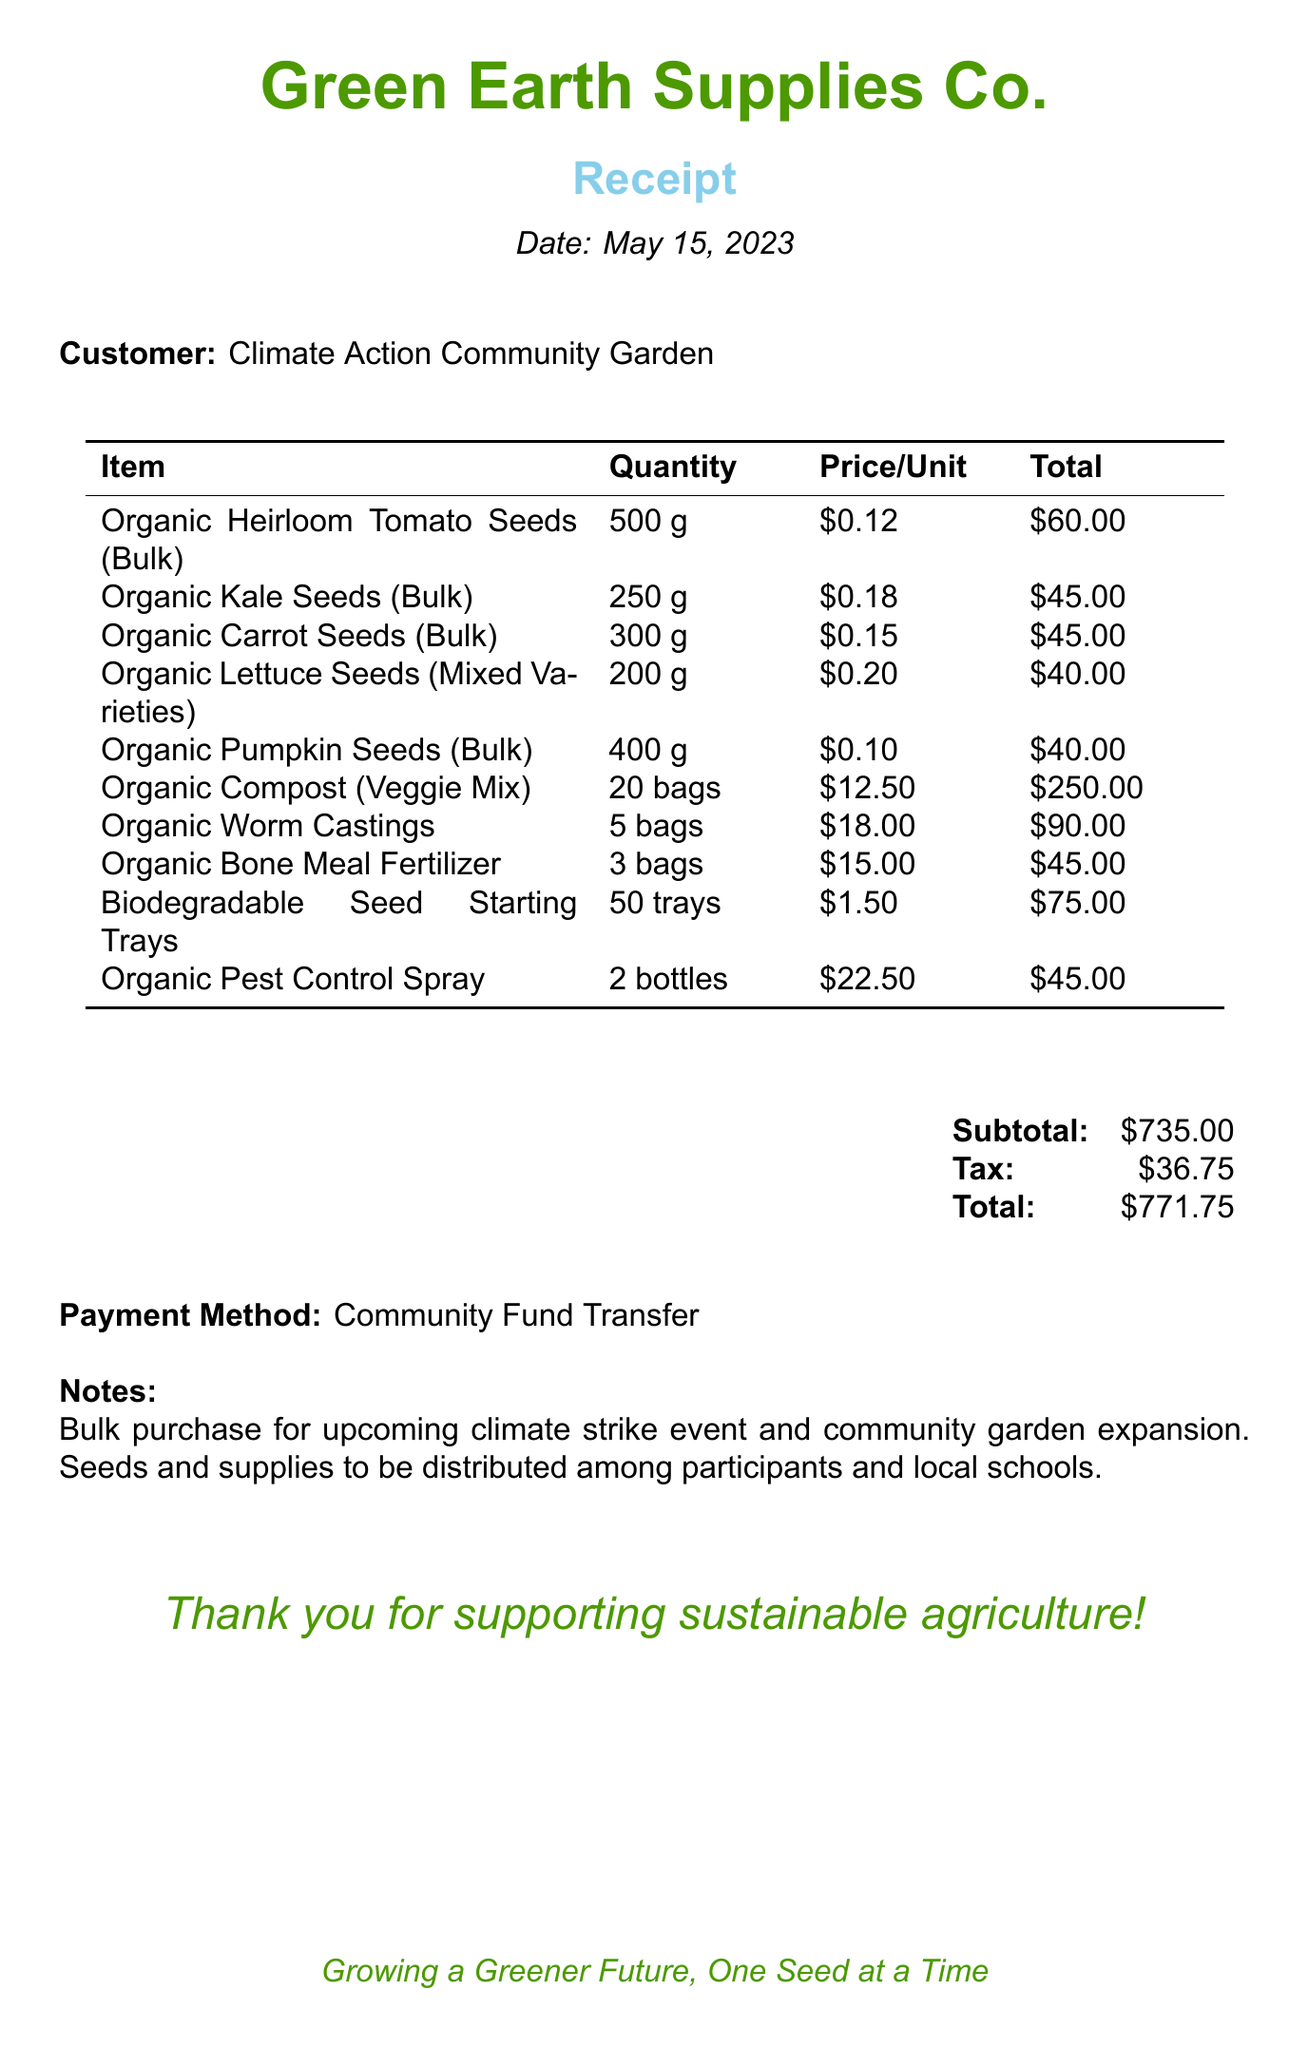What is the store name? The store name is mentioned at the top of the receipt.
Answer: Green Earth Supplies Co What date is the receipt issued? The date of the transaction is displayed under the title "Receipt."
Answer: May 15, 2023 What is the total amount paid? The total amount is calculated including subtotal and tax.
Answer: $771.75 How many grams of Organic Heirloom Tomato Seeds were purchased? The quantity of Organic Heirloom Tomato Seeds is listed in the itemized section.
Answer: 500 grams What type of payment was used? The payment method is indicated towards the end of the receipt.
Answer: Community Fund Transfer What is the subtotal before tax? The subtotal is displayed in the financial summary section before tax is added.
Answer: $735.00 How many bags of Organic Compost were bought? The quantity is clearly stated in the items list on the receipt.
Answer: 20 bags What products will be distributed among participants and local schools? The notes section mentions the purpose of the purchase, focusing on seeds and supplies.
Answer: Seeds and supplies What is the price per unit of Organic Worm Castings? The price per unit is shown next to the item in the list.
Answer: $18.00 